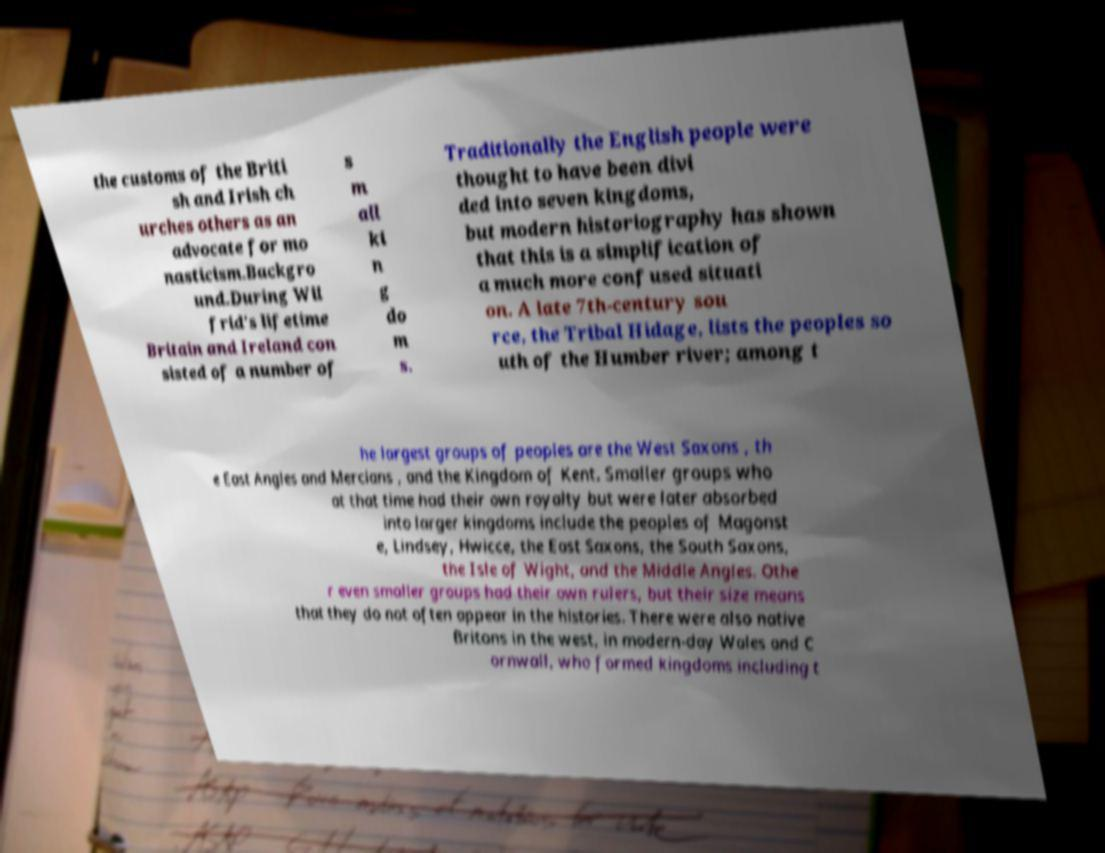Can you read and provide the text displayed in the image?This photo seems to have some interesting text. Can you extract and type it out for me? the customs of the Briti sh and Irish ch urches others as an advocate for mo nasticism.Backgro und.During Wil frid's lifetime Britain and Ireland con sisted of a number of s m all ki n g do m s. Traditionally the English people were thought to have been divi ded into seven kingdoms, but modern historiography has shown that this is a simplification of a much more confused situati on. A late 7th-century sou rce, the Tribal Hidage, lists the peoples so uth of the Humber river; among t he largest groups of peoples are the West Saxons , th e East Angles and Mercians , and the Kingdom of Kent. Smaller groups who at that time had their own royalty but were later absorbed into larger kingdoms include the peoples of Magonst e, Lindsey, Hwicce, the East Saxons, the South Saxons, the Isle of Wight, and the Middle Angles. Othe r even smaller groups had their own rulers, but their size means that they do not often appear in the histories. There were also native Britons in the west, in modern-day Wales and C ornwall, who formed kingdoms including t 